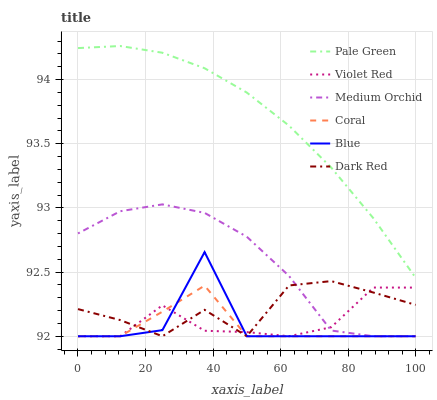Does Coral have the minimum area under the curve?
Answer yes or no. Yes. Does Pale Green have the maximum area under the curve?
Answer yes or no. Yes. Does Violet Red have the minimum area under the curve?
Answer yes or no. No. Does Violet Red have the maximum area under the curve?
Answer yes or no. No. Is Pale Green the smoothest?
Answer yes or no. Yes. Is Blue the roughest?
Answer yes or no. Yes. Is Violet Red the smoothest?
Answer yes or no. No. Is Violet Red the roughest?
Answer yes or no. No. Does Pale Green have the lowest value?
Answer yes or no. No. Does Pale Green have the highest value?
Answer yes or no. Yes. Does Dark Red have the highest value?
Answer yes or no. No. Is Medium Orchid less than Pale Green?
Answer yes or no. Yes. Is Pale Green greater than Coral?
Answer yes or no. Yes. Does Medium Orchid intersect Pale Green?
Answer yes or no. No. 